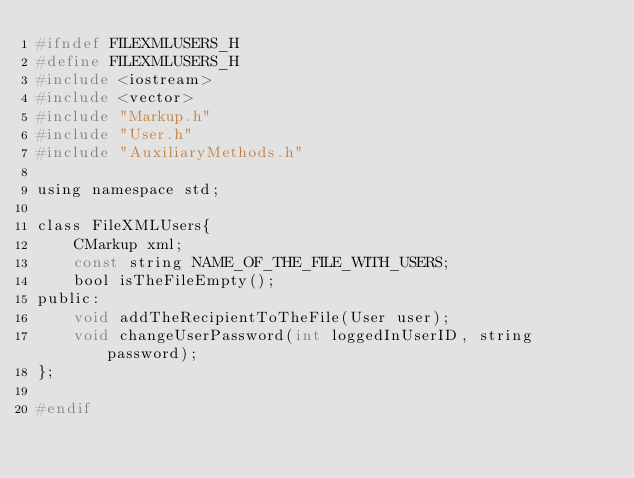<code> <loc_0><loc_0><loc_500><loc_500><_C_>#ifndef FILEXMLUSERS_H
#define FILEXMLUSERS_H
#include <iostream>
#include <vector>
#include "Markup.h"
#include "User.h"
#include "AuxiliaryMethods.h"

using namespace std;

class FileXMLUsers{
    CMarkup xml;
    const string NAME_OF_THE_FILE_WITH_USERS;
    bool isTheFileEmpty();
public:
    void addTheRecipientToTheFile(User user);
    void changeUserPassword(int loggedInUserID, string password);
};

#endif
</code> 